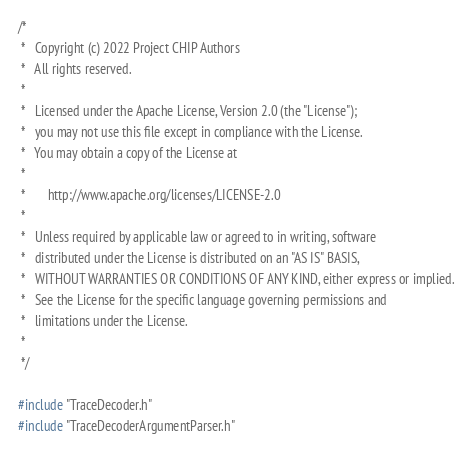<code> <loc_0><loc_0><loc_500><loc_500><_C++_>/*
 *   Copyright (c) 2022 Project CHIP Authors
 *   All rights reserved.
 *
 *   Licensed under the Apache License, Version 2.0 (the "License");
 *   you may not use this file except in compliance with the License.
 *   You may obtain a copy of the License at
 *
 *       http://www.apache.org/licenses/LICENSE-2.0
 *
 *   Unless required by applicable law or agreed to in writing, software
 *   distributed under the License is distributed on an "AS IS" BASIS,
 *   WITHOUT WARRANTIES OR CONDITIONS OF ANY KIND, either express or implied.
 *   See the License for the specific language governing permissions and
 *   limitations under the License.
 *
 */

#include "TraceDecoder.h"
#include "TraceDecoderArgumentParser.h"
</code> 